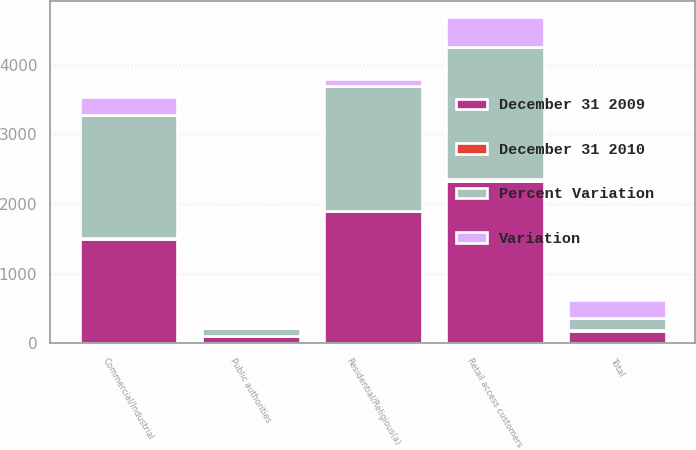<chart> <loc_0><loc_0><loc_500><loc_500><stacked_bar_chart><ecel><fcel>Residential/Religious(a)<fcel>Commercial/Industrial<fcel>Retail access customers<fcel>Public authorities<fcel>Total<nl><fcel>December 31 2009<fcel>1893<fcel>1495<fcel>2330<fcel>110<fcel>182.5<nl><fcel>Percent Variation<fcel>1799<fcel>1763<fcel>1901<fcel>111<fcel>182.5<nl><fcel>Variation<fcel>94<fcel>268<fcel>429<fcel>1<fcel>254<nl><fcel>December 31 2010<fcel>5.2<fcel>15.2<fcel>22.6<fcel>0.9<fcel>4.6<nl></chart> 